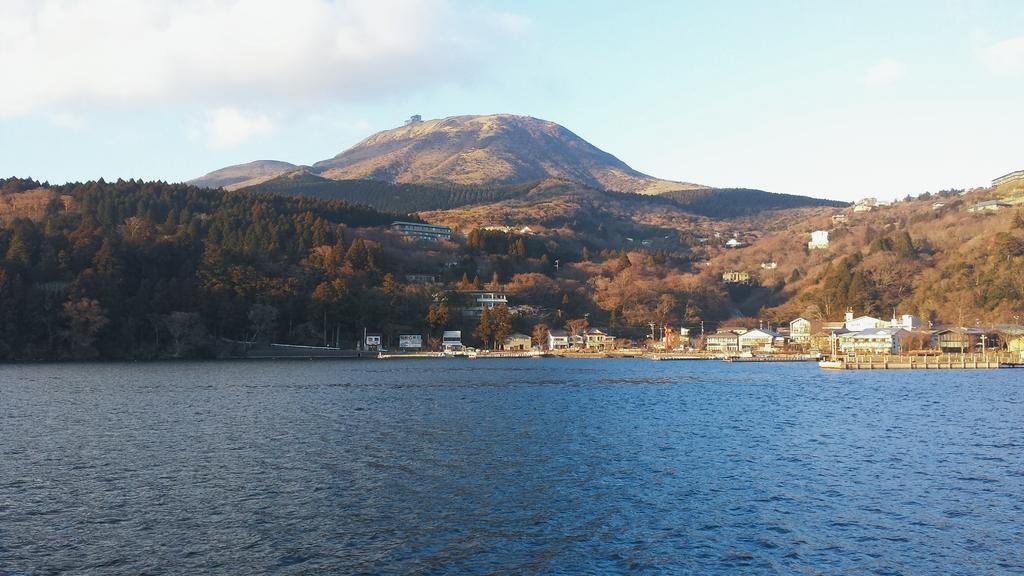Describe this image in one or two sentences. In this picture I can see there is a river, buildings, trees, mountains and the sky is clear. 